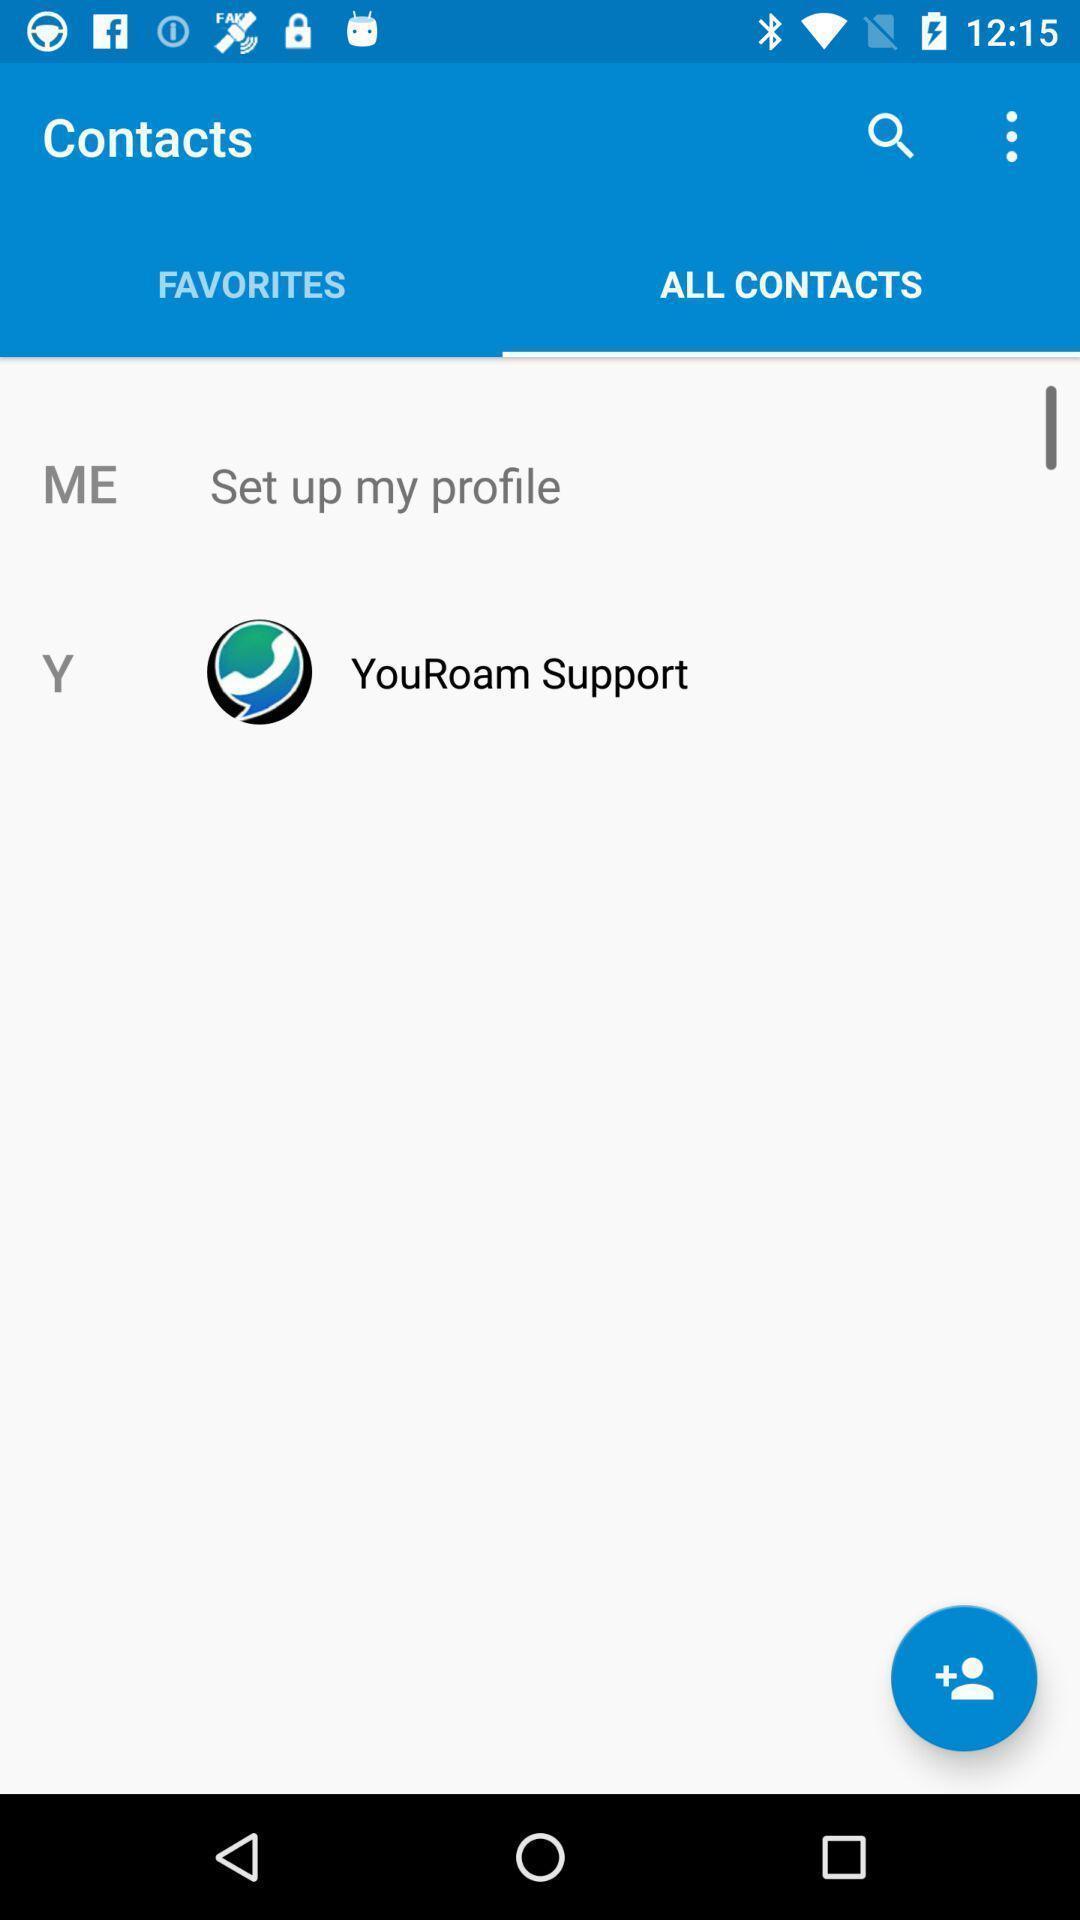Give me a summary of this screen capture. Window displaying with contacts page. 